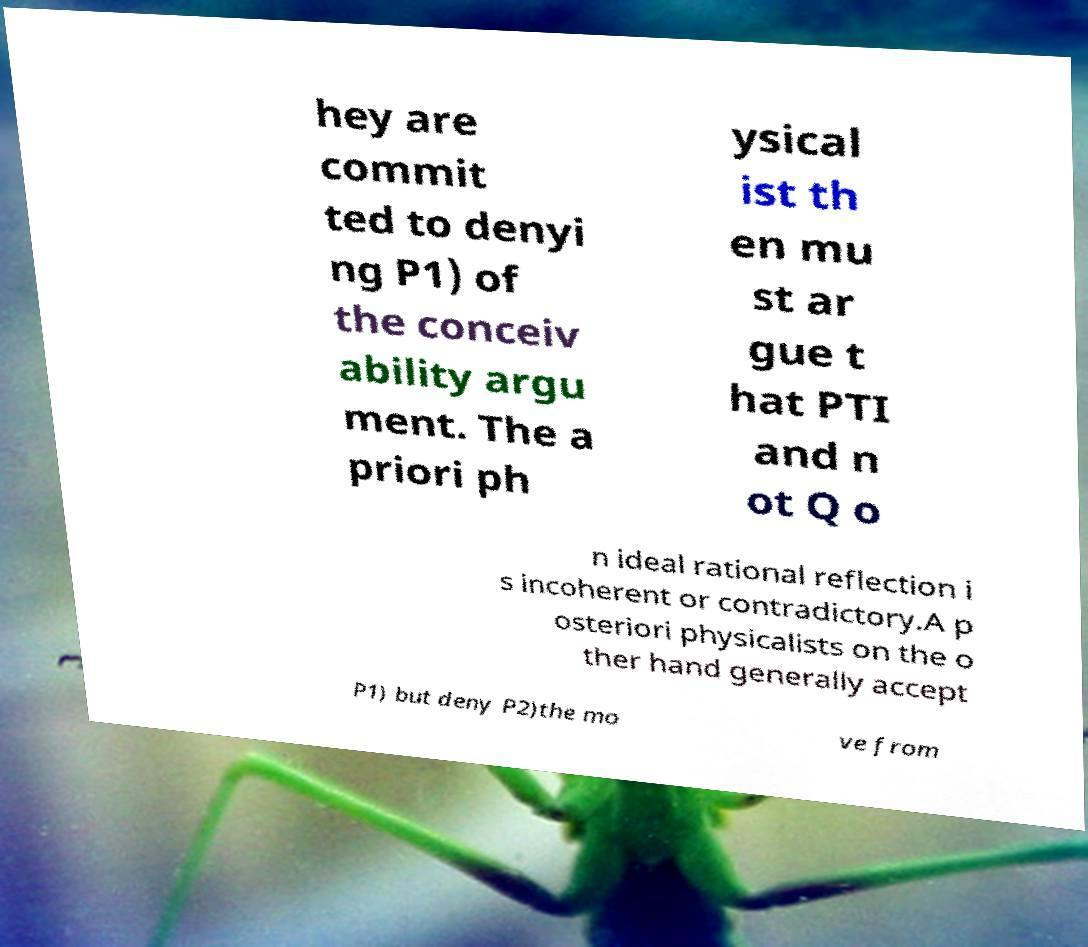What messages or text are displayed in this image? I need them in a readable, typed format. hey are commit ted to denyi ng P1) of the conceiv ability argu ment. The a priori ph ysical ist th en mu st ar gue t hat PTI and n ot Q o n ideal rational reflection i s incoherent or contradictory.A p osteriori physicalists on the o ther hand generally accept P1) but deny P2)the mo ve from 